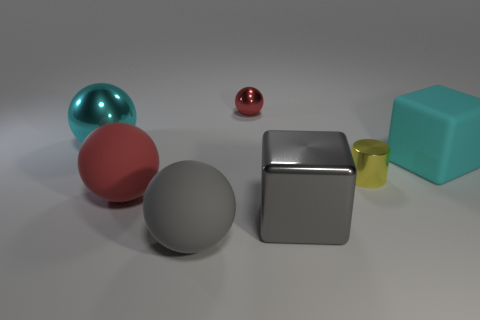Subtract all purple spheres. Subtract all green cubes. How many spheres are left? 4 Add 2 cyan metal spheres. How many objects exist? 9 Subtract all balls. How many objects are left? 3 Add 4 tiny gray rubber things. How many tiny gray rubber things exist? 4 Subtract 1 gray spheres. How many objects are left? 6 Subtract all matte spheres. Subtract all metal objects. How many objects are left? 1 Add 1 tiny objects. How many tiny objects are left? 3 